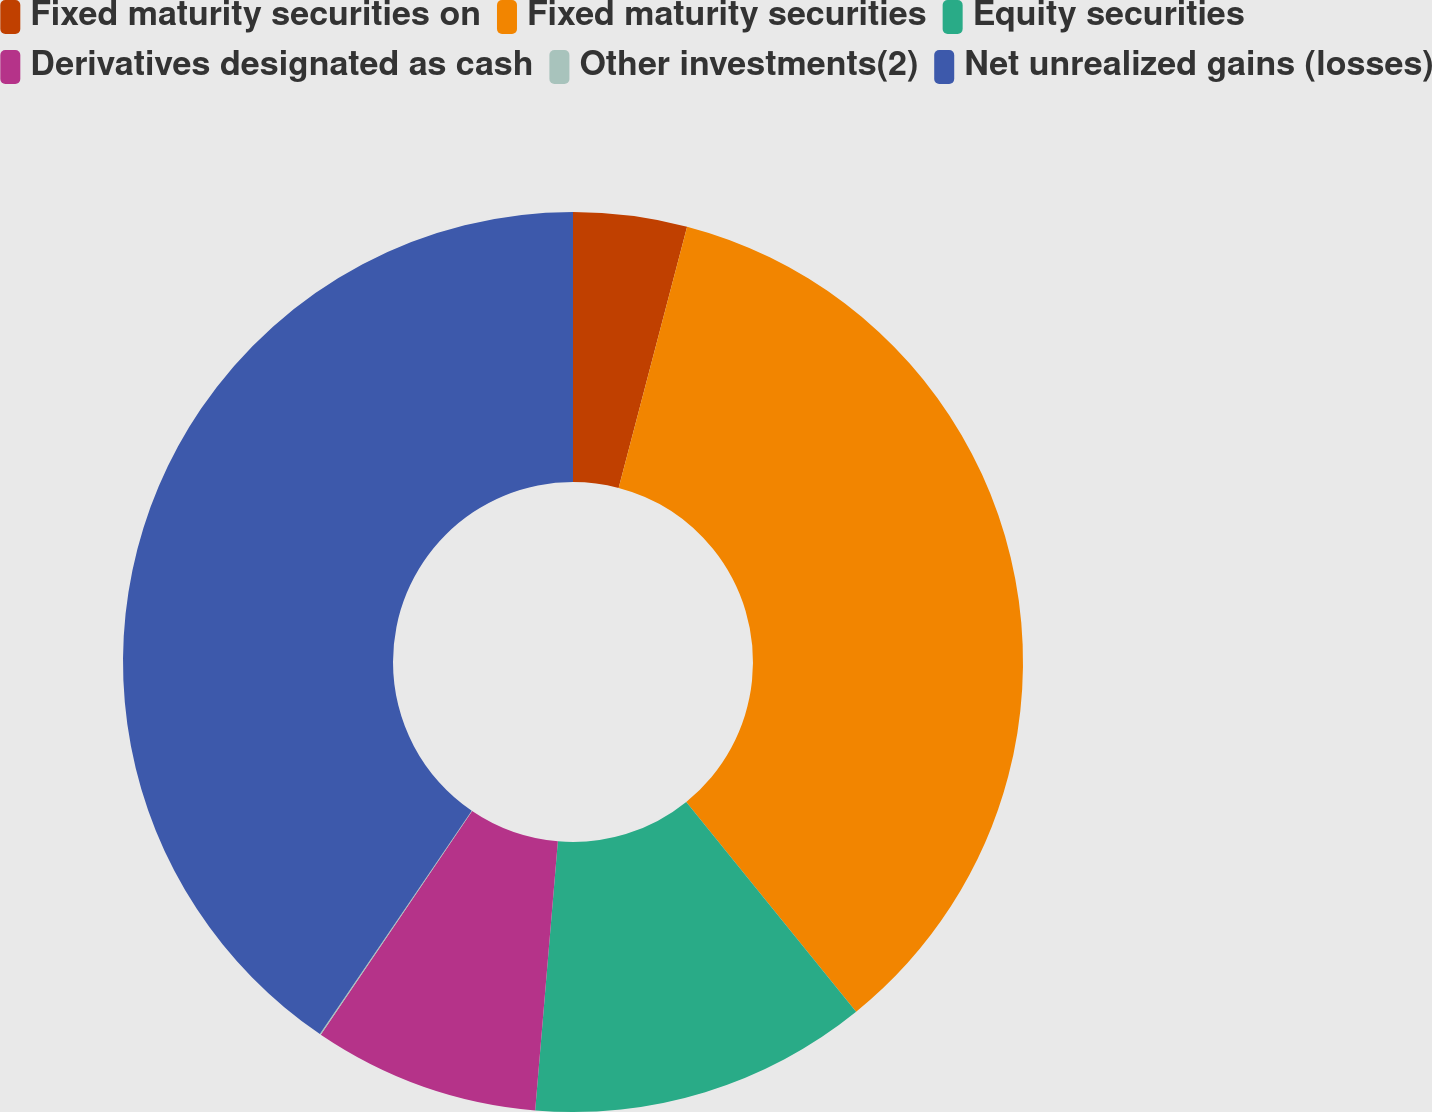Convert chart. <chart><loc_0><loc_0><loc_500><loc_500><pie_chart><fcel>Fixed maturity securities on<fcel>Fixed maturity securities<fcel>Equity securities<fcel>Derivatives designated as cash<fcel>Other investments(2)<fcel>Net unrealized gains (losses)<nl><fcel>4.08%<fcel>35.09%<fcel>12.17%<fcel>8.13%<fcel>0.04%<fcel>40.49%<nl></chart> 